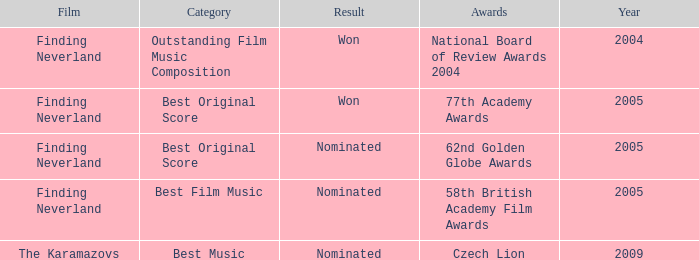What was the result for years prior to 2005? Won. Write the full table. {'header': ['Film', 'Category', 'Result', 'Awards', 'Year'], 'rows': [['Finding Neverland', 'Outstanding Film Music Composition', 'Won', 'National Board of Review Awards 2004', '2004'], ['Finding Neverland', 'Best Original Score', 'Won', '77th Academy Awards', '2005'], ['Finding Neverland', 'Best Original Score', 'Nominated', '62nd Golden Globe Awards', '2005'], ['Finding Neverland', 'Best Film Music', 'Nominated', '58th British Academy Film Awards', '2005'], ['The Karamazovs', 'Best Music', 'Nominated', 'Czech Lion', '2009']]} 